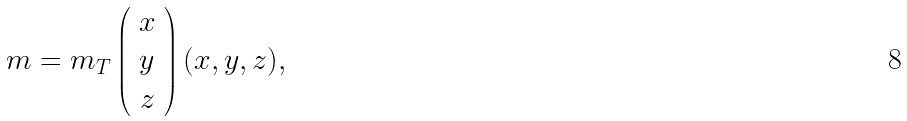<formula> <loc_0><loc_0><loc_500><loc_500>m = m _ { T } \left ( \begin{array} { c } x \\ y \\ z \end{array} \right ) ( x , y , z ) ,</formula> 